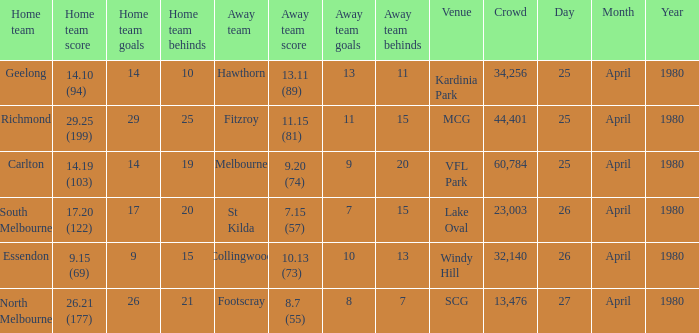On what date did the match at Lake Oval take place? 26 April 1980. Could you parse the entire table as a dict? {'header': ['Home team', 'Home team score', 'Home team goals', 'Home team behinds', 'Away team', 'Away team score', 'Away team goals', 'Away team behinds', 'Venue', 'Crowd', 'Day', 'Month', 'Year'], 'rows': [['Geelong', '14.10 (94)', '14', '10', 'Hawthorn', '13.11 (89)', '13', '11', 'Kardinia Park', '34,256', '25', 'April', '1980'], ['Richmond', '29.25 (199)', '29', '25', 'Fitzroy', '11.15 (81)', '11', '15', 'MCG', '44,401', '25', 'April', '1980'], ['Carlton', '14.19 (103)', '14', '19', 'Melbourne', '9.20 (74)', '9', '20', 'VFL Park', '60,784', '25', 'April', '1980'], ['South Melbourne', '17.20 (122)', '17', '20', 'St Kilda', '7.15 (57)', '7', '15', 'Lake Oval', '23,003', '26', 'April', '1980'], ['Essendon', '9.15 (69)', '9', '15', 'Collingwood', '10.13 (73)', '10', '13', 'Windy Hill', '32,140', '26', 'April', '1980'], ['North Melbourne', '26.21 (177)', '26', '21', 'Footscray', '8.7 (55)', '8', '7', 'SCG', '13,476', '27', 'April', '1980']]} 